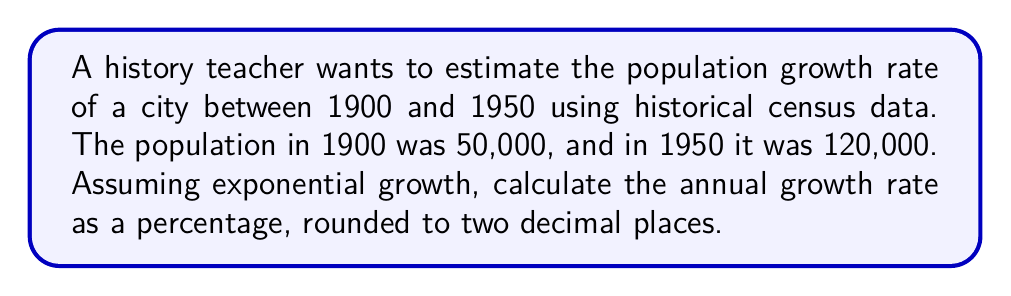Can you answer this question? To solve this problem, we'll use the exponential growth formula and follow these steps:

1. The exponential growth formula is:
   $$P(t) = P_0 \cdot e^{rt}$$
   where $P(t)$ is the population at time $t$, $P_0$ is the initial population, $r$ is the growth rate, and $t$ is the time period.

2. We know:
   $P_0 = 50,000$ (population in 1900)
   $P(t) = 120,000$ (population in 1950)
   $t = 50$ years

3. Substitute these values into the formula:
   $$120,000 = 50,000 \cdot e^{50r}$$

4. Divide both sides by 50,000:
   $$\frac{120,000}{50,000} = e^{50r}$$
   $$2.4 = e^{50r}$$

5. Take the natural logarithm of both sides:
   $$\ln(2.4) = \ln(e^{50r})$$
   $$\ln(2.4) = 50r$$

6. Solve for $r$:
   $$r = \frac{\ln(2.4)}{50}$$
   $$r \approx 0.0175$$

7. Convert to a percentage by multiplying by 100:
   $$r \approx 0.0175 \cdot 100 = 1.75\%$$

8. Round to two decimal places:
   $$r \approx 1.75\%$$
Answer: 1.75% 